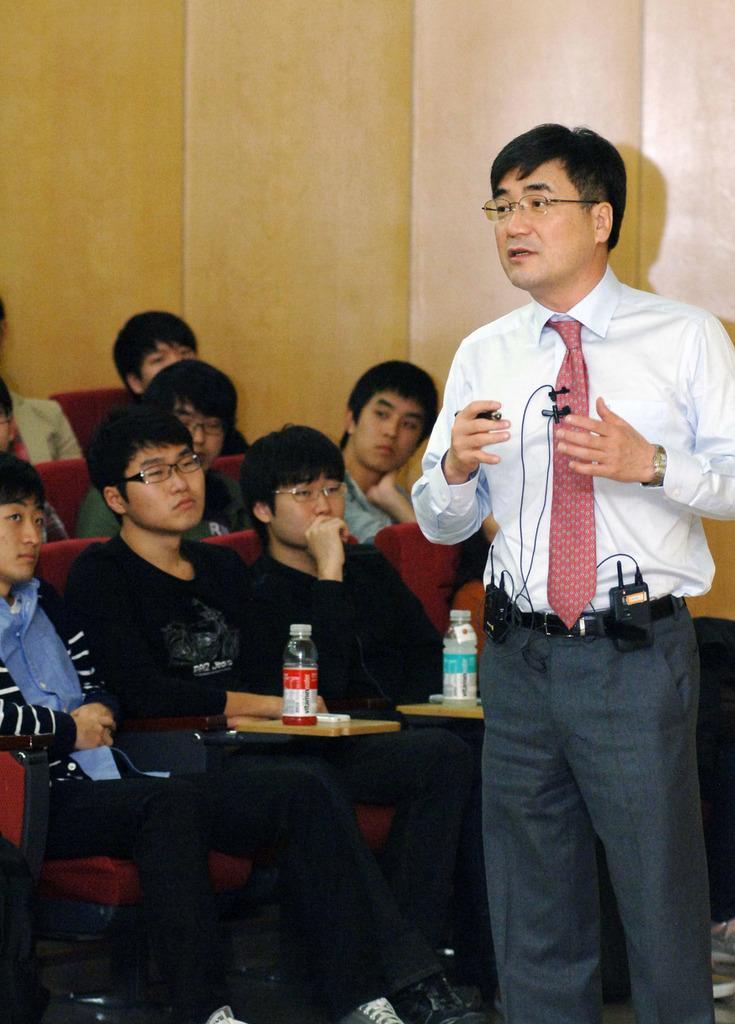Can you describe this image briefly? In this image I can see a group of people sitting in three rows and I can see two water bottles in the first row. I can see a person standing facing towards the left on the right side of the image. 